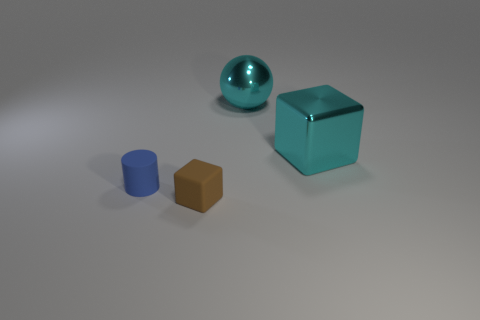Add 3 cyan metallic balls. How many objects exist? 7 Add 1 spheres. How many spheres are left? 2 Add 4 tiny brown rubber cubes. How many tiny brown rubber cubes exist? 5 Subtract 1 cyan blocks. How many objects are left? 3 Subtract all rubber balls. Subtract all brown cubes. How many objects are left? 3 